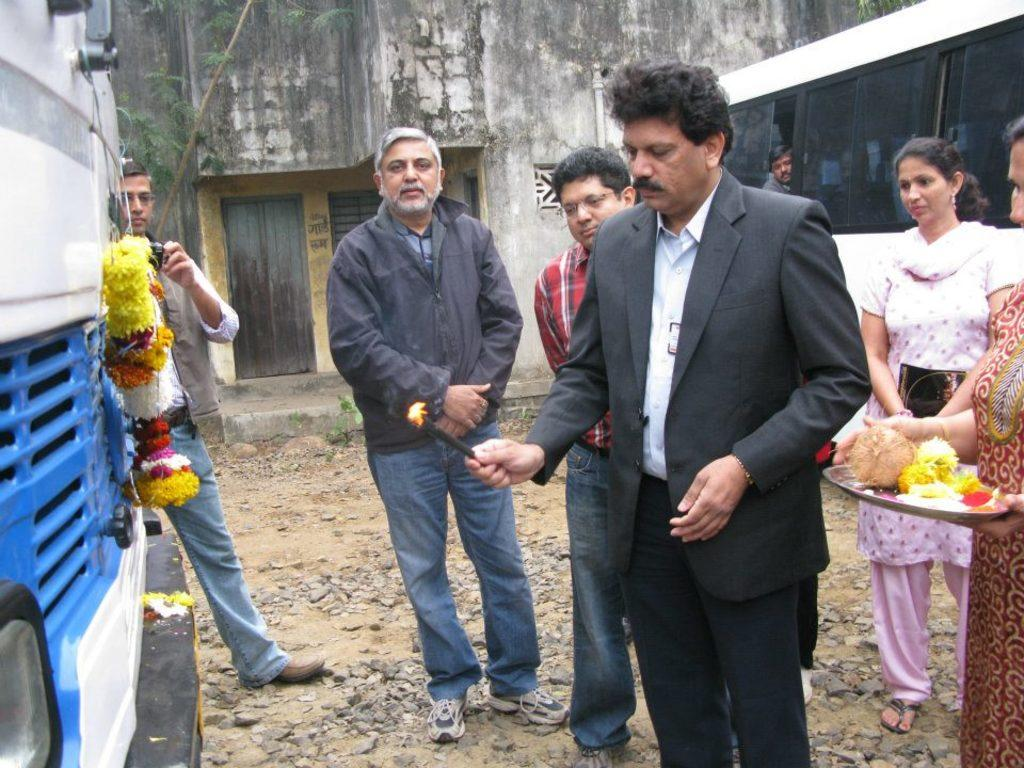Who is the main subject in the image? There is a man in the image. What is the man doing in the image? The man is inaugurating a vehicle. Are there any other people present in the image? Yes, there are other people around the man. What can be seen in the background of the image? There is a wall in the background of the image. What is in front of the wall? There is a bus in front of the wall. What type of drain can be seen in the image? There is no drain present in the image. Is there a ship visible in the image? No, there is no ship visible in the image. 